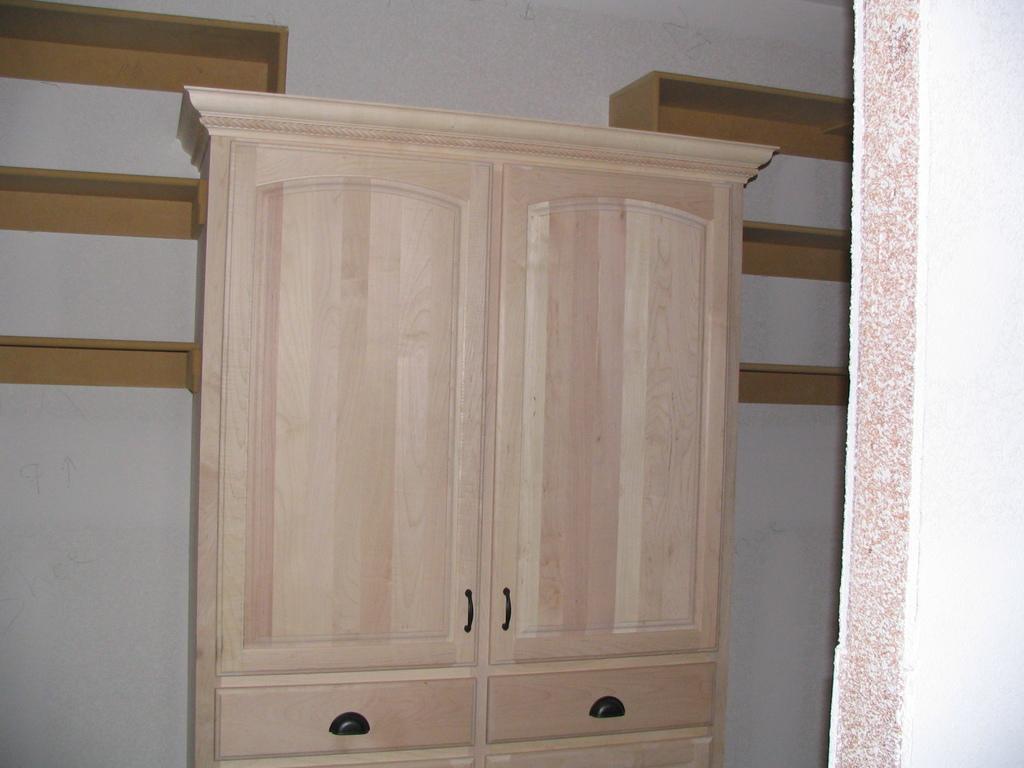In one or two sentences, can you explain what this image depicts? In this picture we can see a cupboard and in the background we can see a wall and shelves. 